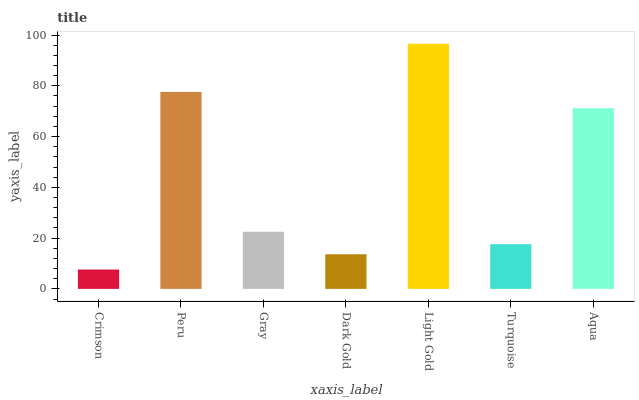Is Crimson the minimum?
Answer yes or no. Yes. Is Light Gold the maximum?
Answer yes or no. Yes. Is Peru the minimum?
Answer yes or no. No. Is Peru the maximum?
Answer yes or no. No. Is Peru greater than Crimson?
Answer yes or no. Yes. Is Crimson less than Peru?
Answer yes or no. Yes. Is Crimson greater than Peru?
Answer yes or no. No. Is Peru less than Crimson?
Answer yes or no. No. Is Gray the high median?
Answer yes or no. Yes. Is Gray the low median?
Answer yes or no. Yes. Is Aqua the high median?
Answer yes or no. No. Is Crimson the low median?
Answer yes or no. No. 